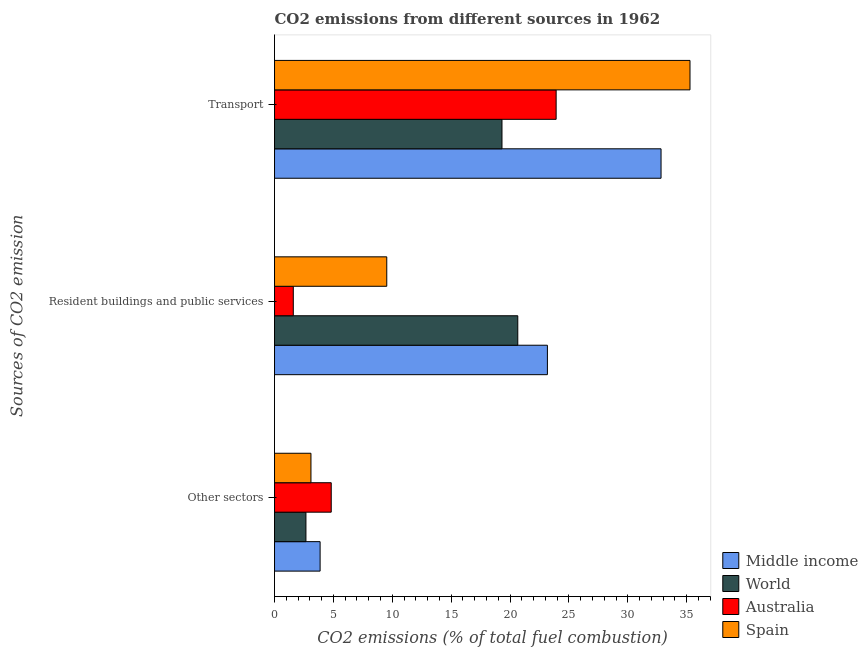How many groups of bars are there?
Your answer should be compact. 3. Are the number of bars per tick equal to the number of legend labels?
Ensure brevity in your answer.  Yes. What is the label of the 1st group of bars from the top?
Your response must be concise. Transport. What is the percentage of co2 emissions from resident buildings and public services in World?
Your answer should be very brief. 20.66. Across all countries, what is the maximum percentage of co2 emissions from transport?
Offer a terse response. 35.28. Across all countries, what is the minimum percentage of co2 emissions from resident buildings and public services?
Keep it short and to the point. 1.59. In which country was the percentage of co2 emissions from other sectors maximum?
Keep it short and to the point. Australia. What is the total percentage of co2 emissions from other sectors in the graph?
Your answer should be very brief. 14.45. What is the difference between the percentage of co2 emissions from transport in Spain and that in Australia?
Give a very brief answer. 11.37. What is the difference between the percentage of co2 emissions from resident buildings and public services in Australia and the percentage of co2 emissions from other sectors in World?
Provide a succinct answer. -1.07. What is the average percentage of co2 emissions from resident buildings and public services per country?
Your answer should be compact. 13.74. What is the difference between the percentage of co2 emissions from transport and percentage of co2 emissions from resident buildings and public services in Spain?
Your answer should be compact. 25.75. What is the ratio of the percentage of co2 emissions from resident buildings and public services in Australia to that in Middle income?
Offer a very short reply. 0.07. Is the percentage of co2 emissions from other sectors in Australia less than that in World?
Make the answer very short. No. What is the difference between the highest and the second highest percentage of co2 emissions from transport?
Ensure brevity in your answer.  2.46. What is the difference between the highest and the lowest percentage of co2 emissions from resident buildings and public services?
Make the answer very short. 21.58. Is the sum of the percentage of co2 emissions from resident buildings and public services in Middle income and Australia greater than the maximum percentage of co2 emissions from transport across all countries?
Your answer should be compact. No. Is it the case that in every country, the sum of the percentage of co2 emissions from other sectors and percentage of co2 emissions from resident buildings and public services is greater than the percentage of co2 emissions from transport?
Make the answer very short. No. How many bars are there?
Ensure brevity in your answer.  12. What is the difference between two consecutive major ticks on the X-axis?
Make the answer very short. 5. What is the title of the graph?
Your response must be concise. CO2 emissions from different sources in 1962. What is the label or title of the X-axis?
Provide a short and direct response. CO2 emissions (% of total fuel combustion). What is the label or title of the Y-axis?
Make the answer very short. Sources of CO2 emission. What is the CO2 emissions (% of total fuel combustion) in Middle income in Other sectors?
Provide a succinct answer. 3.87. What is the CO2 emissions (% of total fuel combustion) in World in Other sectors?
Give a very brief answer. 2.67. What is the CO2 emissions (% of total fuel combustion) in Australia in Other sectors?
Offer a terse response. 4.82. What is the CO2 emissions (% of total fuel combustion) of Spain in Other sectors?
Your answer should be compact. 3.09. What is the CO2 emissions (% of total fuel combustion) of Middle income in Resident buildings and public services?
Ensure brevity in your answer.  23.17. What is the CO2 emissions (% of total fuel combustion) of World in Resident buildings and public services?
Provide a short and direct response. 20.66. What is the CO2 emissions (% of total fuel combustion) in Australia in Resident buildings and public services?
Keep it short and to the point. 1.59. What is the CO2 emissions (% of total fuel combustion) of Spain in Resident buildings and public services?
Make the answer very short. 9.53. What is the CO2 emissions (% of total fuel combustion) in Middle income in Transport?
Your answer should be very brief. 32.82. What is the CO2 emissions (% of total fuel combustion) in World in Transport?
Ensure brevity in your answer.  19.32. What is the CO2 emissions (% of total fuel combustion) in Australia in Transport?
Provide a short and direct response. 23.92. What is the CO2 emissions (% of total fuel combustion) of Spain in Transport?
Ensure brevity in your answer.  35.28. Across all Sources of CO2 emission, what is the maximum CO2 emissions (% of total fuel combustion) in Middle income?
Give a very brief answer. 32.82. Across all Sources of CO2 emission, what is the maximum CO2 emissions (% of total fuel combustion) in World?
Your answer should be compact. 20.66. Across all Sources of CO2 emission, what is the maximum CO2 emissions (% of total fuel combustion) in Australia?
Your response must be concise. 23.92. Across all Sources of CO2 emission, what is the maximum CO2 emissions (% of total fuel combustion) in Spain?
Make the answer very short. 35.28. Across all Sources of CO2 emission, what is the minimum CO2 emissions (% of total fuel combustion) of Middle income?
Provide a short and direct response. 3.87. Across all Sources of CO2 emission, what is the minimum CO2 emissions (% of total fuel combustion) of World?
Provide a short and direct response. 2.67. Across all Sources of CO2 emission, what is the minimum CO2 emissions (% of total fuel combustion) of Australia?
Make the answer very short. 1.59. Across all Sources of CO2 emission, what is the minimum CO2 emissions (% of total fuel combustion) of Spain?
Offer a very short reply. 3.09. What is the total CO2 emissions (% of total fuel combustion) in Middle income in the graph?
Make the answer very short. 59.87. What is the total CO2 emissions (% of total fuel combustion) in World in the graph?
Your answer should be compact. 42.64. What is the total CO2 emissions (% of total fuel combustion) in Australia in the graph?
Give a very brief answer. 30.33. What is the total CO2 emissions (% of total fuel combustion) in Spain in the graph?
Ensure brevity in your answer.  47.91. What is the difference between the CO2 emissions (% of total fuel combustion) of Middle income in Other sectors and that in Resident buildings and public services?
Ensure brevity in your answer.  -19.3. What is the difference between the CO2 emissions (% of total fuel combustion) of World in Other sectors and that in Resident buildings and public services?
Your response must be concise. -17.99. What is the difference between the CO2 emissions (% of total fuel combustion) in Australia in Other sectors and that in Resident buildings and public services?
Offer a very short reply. 3.22. What is the difference between the CO2 emissions (% of total fuel combustion) of Spain in Other sectors and that in Resident buildings and public services?
Provide a succinct answer. -6.44. What is the difference between the CO2 emissions (% of total fuel combustion) in Middle income in Other sectors and that in Transport?
Offer a terse response. -28.95. What is the difference between the CO2 emissions (% of total fuel combustion) in World in Other sectors and that in Transport?
Keep it short and to the point. -16.65. What is the difference between the CO2 emissions (% of total fuel combustion) of Australia in Other sectors and that in Transport?
Make the answer very short. -19.1. What is the difference between the CO2 emissions (% of total fuel combustion) in Spain in Other sectors and that in Transport?
Your answer should be compact. -32.19. What is the difference between the CO2 emissions (% of total fuel combustion) in Middle income in Resident buildings and public services and that in Transport?
Your response must be concise. -9.65. What is the difference between the CO2 emissions (% of total fuel combustion) in World in Resident buildings and public services and that in Transport?
Provide a short and direct response. 1.34. What is the difference between the CO2 emissions (% of total fuel combustion) in Australia in Resident buildings and public services and that in Transport?
Offer a very short reply. -22.32. What is the difference between the CO2 emissions (% of total fuel combustion) in Spain in Resident buildings and public services and that in Transport?
Give a very brief answer. -25.75. What is the difference between the CO2 emissions (% of total fuel combustion) of Middle income in Other sectors and the CO2 emissions (% of total fuel combustion) of World in Resident buildings and public services?
Provide a short and direct response. -16.79. What is the difference between the CO2 emissions (% of total fuel combustion) of Middle income in Other sectors and the CO2 emissions (% of total fuel combustion) of Australia in Resident buildings and public services?
Your answer should be compact. 2.28. What is the difference between the CO2 emissions (% of total fuel combustion) of Middle income in Other sectors and the CO2 emissions (% of total fuel combustion) of Spain in Resident buildings and public services?
Ensure brevity in your answer.  -5.66. What is the difference between the CO2 emissions (% of total fuel combustion) of World in Other sectors and the CO2 emissions (% of total fuel combustion) of Australia in Resident buildings and public services?
Your answer should be very brief. 1.07. What is the difference between the CO2 emissions (% of total fuel combustion) of World in Other sectors and the CO2 emissions (% of total fuel combustion) of Spain in Resident buildings and public services?
Your answer should be compact. -6.86. What is the difference between the CO2 emissions (% of total fuel combustion) of Australia in Other sectors and the CO2 emissions (% of total fuel combustion) of Spain in Resident buildings and public services?
Offer a very short reply. -4.72. What is the difference between the CO2 emissions (% of total fuel combustion) in Middle income in Other sectors and the CO2 emissions (% of total fuel combustion) in World in Transport?
Give a very brief answer. -15.45. What is the difference between the CO2 emissions (% of total fuel combustion) in Middle income in Other sectors and the CO2 emissions (% of total fuel combustion) in Australia in Transport?
Give a very brief answer. -20.04. What is the difference between the CO2 emissions (% of total fuel combustion) of Middle income in Other sectors and the CO2 emissions (% of total fuel combustion) of Spain in Transport?
Your answer should be compact. -31.41. What is the difference between the CO2 emissions (% of total fuel combustion) of World in Other sectors and the CO2 emissions (% of total fuel combustion) of Australia in Transport?
Your answer should be compact. -21.25. What is the difference between the CO2 emissions (% of total fuel combustion) of World in Other sectors and the CO2 emissions (% of total fuel combustion) of Spain in Transport?
Give a very brief answer. -32.62. What is the difference between the CO2 emissions (% of total fuel combustion) in Australia in Other sectors and the CO2 emissions (% of total fuel combustion) in Spain in Transport?
Keep it short and to the point. -30.47. What is the difference between the CO2 emissions (% of total fuel combustion) in Middle income in Resident buildings and public services and the CO2 emissions (% of total fuel combustion) in World in Transport?
Ensure brevity in your answer.  3.86. What is the difference between the CO2 emissions (% of total fuel combustion) in Middle income in Resident buildings and public services and the CO2 emissions (% of total fuel combustion) in Australia in Transport?
Provide a succinct answer. -0.74. What is the difference between the CO2 emissions (% of total fuel combustion) in Middle income in Resident buildings and public services and the CO2 emissions (% of total fuel combustion) in Spain in Transport?
Offer a terse response. -12.11. What is the difference between the CO2 emissions (% of total fuel combustion) of World in Resident buildings and public services and the CO2 emissions (% of total fuel combustion) of Australia in Transport?
Give a very brief answer. -3.26. What is the difference between the CO2 emissions (% of total fuel combustion) of World in Resident buildings and public services and the CO2 emissions (% of total fuel combustion) of Spain in Transport?
Give a very brief answer. -14.62. What is the difference between the CO2 emissions (% of total fuel combustion) in Australia in Resident buildings and public services and the CO2 emissions (% of total fuel combustion) in Spain in Transport?
Provide a short and direct response. -33.69. What is the average CO2 emissions (% of total fuel combustion) of Middle income per Sources of CO2 emission?
Your answer should be compact. 19.96. What is the average CO2 emissions (% of total fuel combustion) in World per Sources of CO2 emission?
Your response must be concise. 14.21. What is the average CO2 emissions (% of total fuel combustion) in Australia per Sources of CO2 emission?
Your response must be concise. 10.11. What is the average CO2 emissions (% of total fuel combustion) in Spain per Sources of CO2 emission?
Provide a short and direct response. 15.97. What is the difference between the CO2 emissions (% of total fuel combustion) of Middle income and CO2 emissions (% of total fuel combustion) of World in Other sectors?
Offer a terse response. 1.2. What is the difference between the CO2 emissions (% of total fuel combustion) in Middle income and CO2 emissions (% of total fuel combustion) in Australia in Other sectors?
Keep it short and to the point. -0.94. What is the difference between the CO2 emissions (% of total fuel combustion) of Middle income and CO2 emissions (% of total fuel combustion) of Spain in Other sectors?
Offer a terse response. 0.78. What is the difference between the CO2 emissions (% of total fuel combustion) in World and CO2 emissions (% of total fuel combustion) in Australia in Other sectors?
Make the answer very short. -2.15. What is the difference between the CO2 emissions (% of total fuel combustion) of World and CO2 emissions (% of total fuel combustion) of Spain in Other sectors?
Give a very brief answer. -0.43. What is the difference between the CO2 emissions (% of total fuel combustion) of Australia and CO2 emissions (% of total fuel combustion) of Spain in Other sectors?
Provide a succinct answer. 1.72. What is the difference between the CO2 emissions (% of total fuel combustion) of Middle income and CO2 emissions (% of total fuel combustion) of World in Resident buildings and public services?
Ensure brevity in your answer.  2.52. What is the difference between the CO2 emissions (% of total fuel combustion) in Middle income and CO2 emissions (% of total fuel combustion) in Australia in Resident buildings and public services?
Offer a terse response. 21.58. What is the difference between the CO2 emissions (% of total fuel combustion) in Middle income and CO2 emissions (% of total fuel combustion) in Spain in Resident buildings and public services?
Provide a short and direct response. 13.64. What is the difference between the CO2 emissions (% of total fuel combustion) in World and CO2 emissions (% of total fuel combustion) in Australia in Resident buildings and public services?
Give a very brief answer. 19.06. What is the difference between the CO2 emissions (% of total fuel combustion) in World and CO2 emissions (% of total fuel combustion) in Spain in Resident buildings and public services?
Keep it short and to the point. 11.13. What is the difference between the CO2 emissions (% of total fuel combustion) in Australia and CO2 emissions (% of total fuel combustion) in Spain in Resident buildings and public services?
Keep it short and to the point. -7.94. What is the difference between the CO2 emissions (% of total fuel combustion) of Middle income and CO2 emissions (% of total fuel combustion) of World in Transport?
Keep it short and to the point. 13.51. What is the difference between the CO2 emissions (% of total fuel combustion) in Middle income and CO2 emissions (% of total fuel combustion) in Australia in Transport?
Make the answer very short. 8.91. What is the difference between the CO2 emissions (% of total fuel combustion) in Middle income and CO2 emissions (% of total fuel combustion) in Spain in Transport?
Make the answer very short. -2.46. What is the difference between the CO2 emissions (% of total fuel combustion) in World and CO2 emissions (% of total fuel combustion) in Australia in Transport?
Ensure brevity in your answer.  -4.6. What is the difference between the CO2 emissions (% of total fuel combustion) of World and CO2 emissions (% of total fuel combustion) of Spain in Transport?
Offer a very short reply. -15.97. What is the difference between the CO2 emissions (% of total fuel combustion) in Australia and CO2 emissions (% of total fuel combustion) in Spain in Transport?
Your response must be concise. -11.37. What is the ratio of the CO2 emissions (% of total fuel combustion) of Middle income in Other sectors to that in Resident buildings and public services?
Your response must be concise. 0.17. What is the ratio of the CO2 emissions (% of total fuel combustion) of World in Other sectors to that in Resident buildings and public services?
Make the answer very short. 0.13. What is the ratio of the CO2 emissions (% of total fuel combustion) in Australia in Other sectors to that in Resident buildings and public services?
Your response must be concise. 3.02. What is the ratio of the CO2 emissions (% of total fuel combustion) in Spain in Other sectors to that in Resident buildings and public services?
Offer a very short reply. 0.32. What is the ratio of the CO2 emissions (% of total fuel combustion) of Middle income in Other sectors to that in Transport?
Provide a short and direct response. 0.12. What is the ratio of the CO2 emissions (% of total fuel combustion) in World in Other sectors to that in Transport?
Give a very brief answer. 0.14. What is the ratio of the CO2 emissions (% of total fuel combustion) of Australia in Other sectors to that in Transport?
Ensure brevity in your answer.  0.2. What is the ratio of the CO2 emissions (% of total fuel combustion) of Spain in Other sectors to that in Transport?
Offer a terse response. 0.09. What is the ratio of the CO2 emissions (% of total fuel combustion) in Middle income in Resident buildings and public services to that in Transport?
Your response must be concise. 0.71. What is the ratio of the CO2 emissions (% of total fuel combustion) in World in Resident buildings and public services to that in Transport?
Provide a succinct answer. 1.07. What is the ratio of the CO2 emissions (% of total fuel combustion) of Australia in Resident buildings and public services to that in Transport?
Your response must be concise. 0.07. What is the ratio of the CO2 emissions (% of total fuel combustion) of Spain in Resident buildings and public services to that in Transport?
Give a very brief answer. 0.27. What is the difference between the highest and the second highest CO2 emissions (% of total fuel combustion) in Middle income?
Ensure brevity in your answer.  9.65. What is the difference between the highest and the second highest CO2 emissions (% of total fuel combustion) in World?
Offer a terse response. 1.34. What is the difference between the highest and the second highest CO2 emissions (% of total fuel combustion) in Australia?
Keep it short and to the point. 19.1. What is the difference between the highest and the second highest CO2 emissions (% of total fuel combustion) in Spain?
Offer a very short reply. 25.75. What is the difference between the highest and the lowest CO2 emissions (% of total fuel combustion) in Middle income?
Your response must be concise. 28.95. What is the difference between the highest and the lowest CO2 emissions (% of total fuel combustion) in World?
Your answer should be very brief. 17.99. What is the difference between the highest and the lowest CO2 emissions (% of total fuel combustion) in Australia?
Offer a very short reply. 22.32. What is the difference between the highest and the lowest CO2 emissions (% of total fuel combustion) in Spain?
Offer a very short reply. 32.19. 